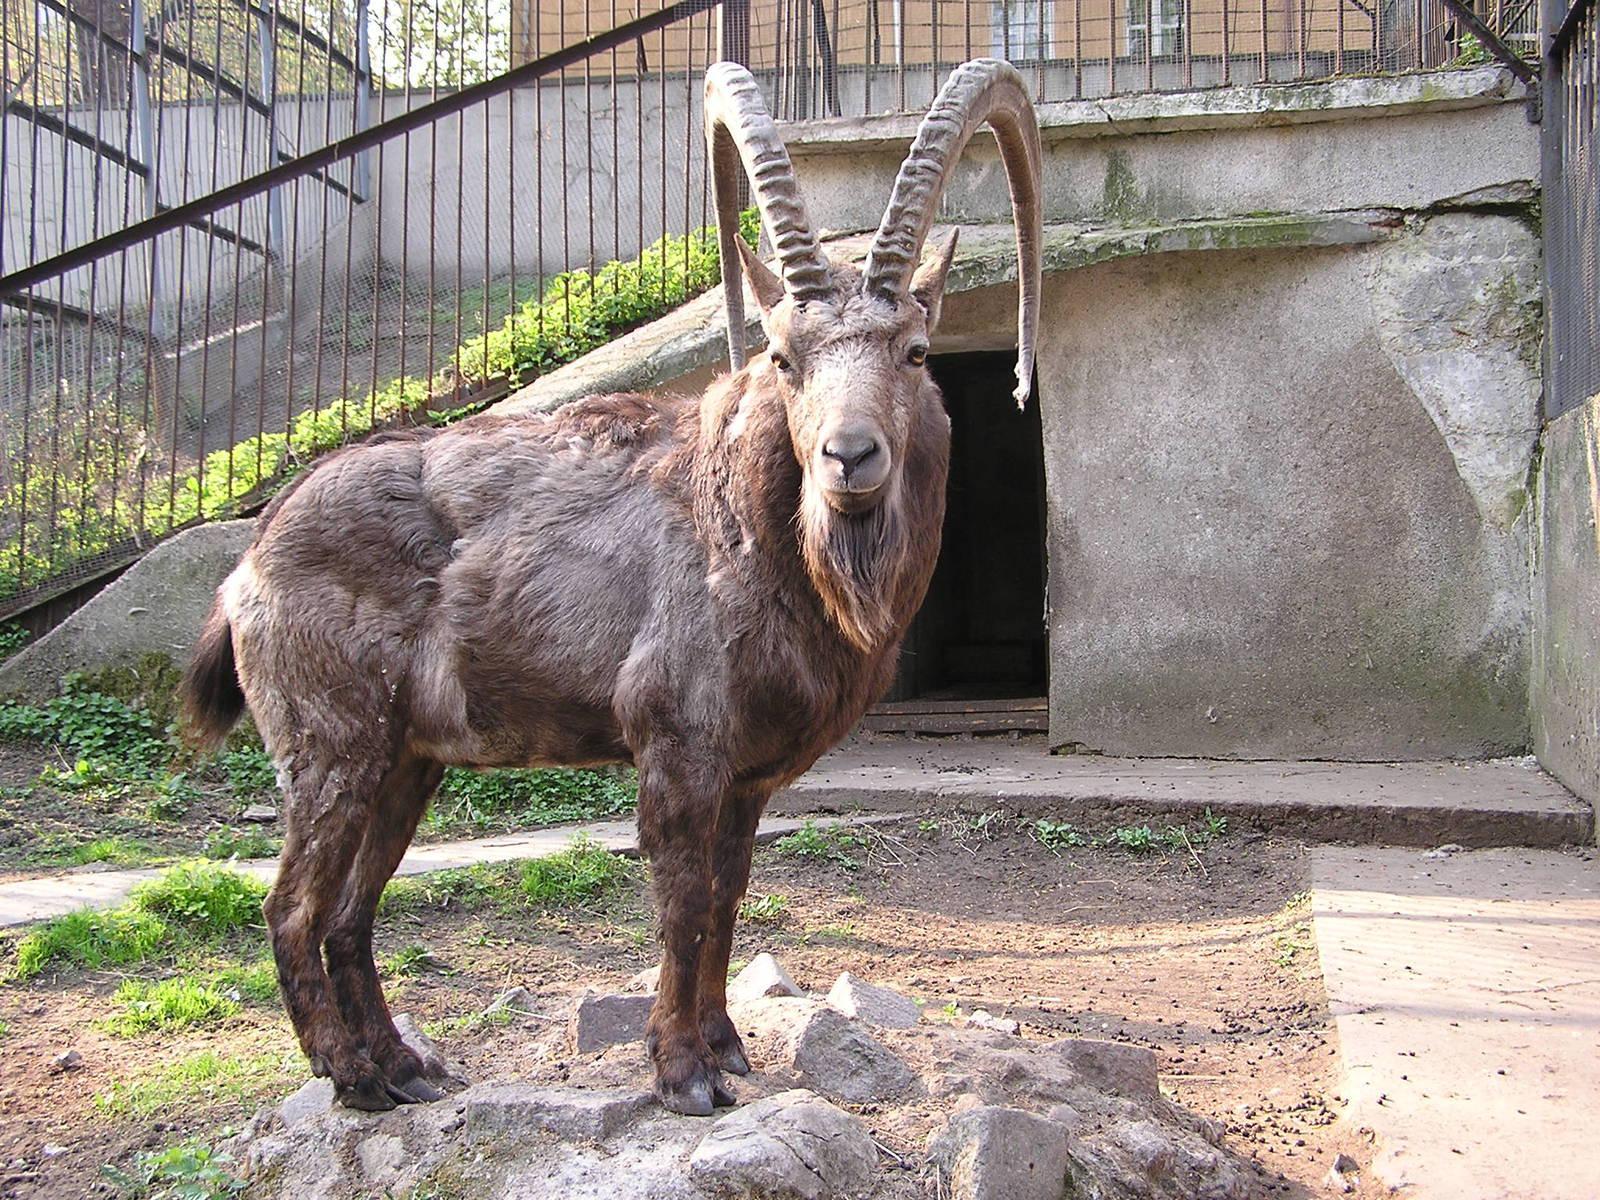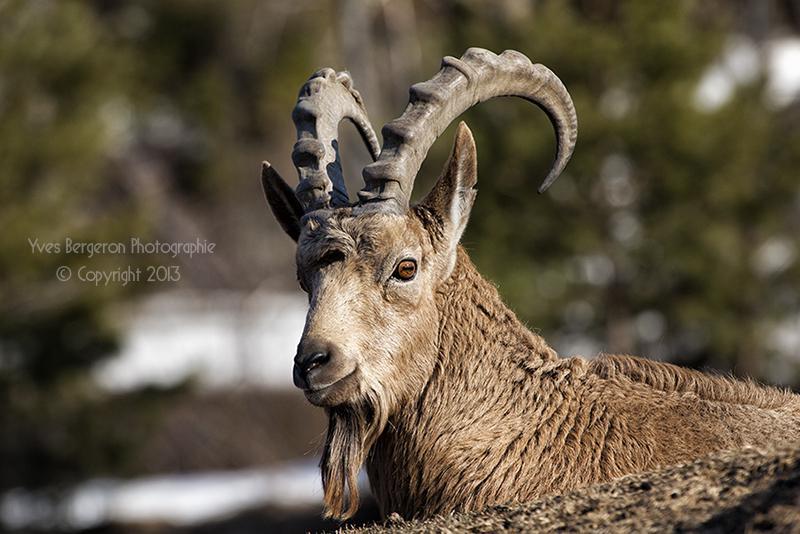The first image is the image on the left, the second image is the image on the right. Examine the images to the left and right. Is the description "The animals are facing the same way in both images of the pair." accurate? Answer yes or no. No. 